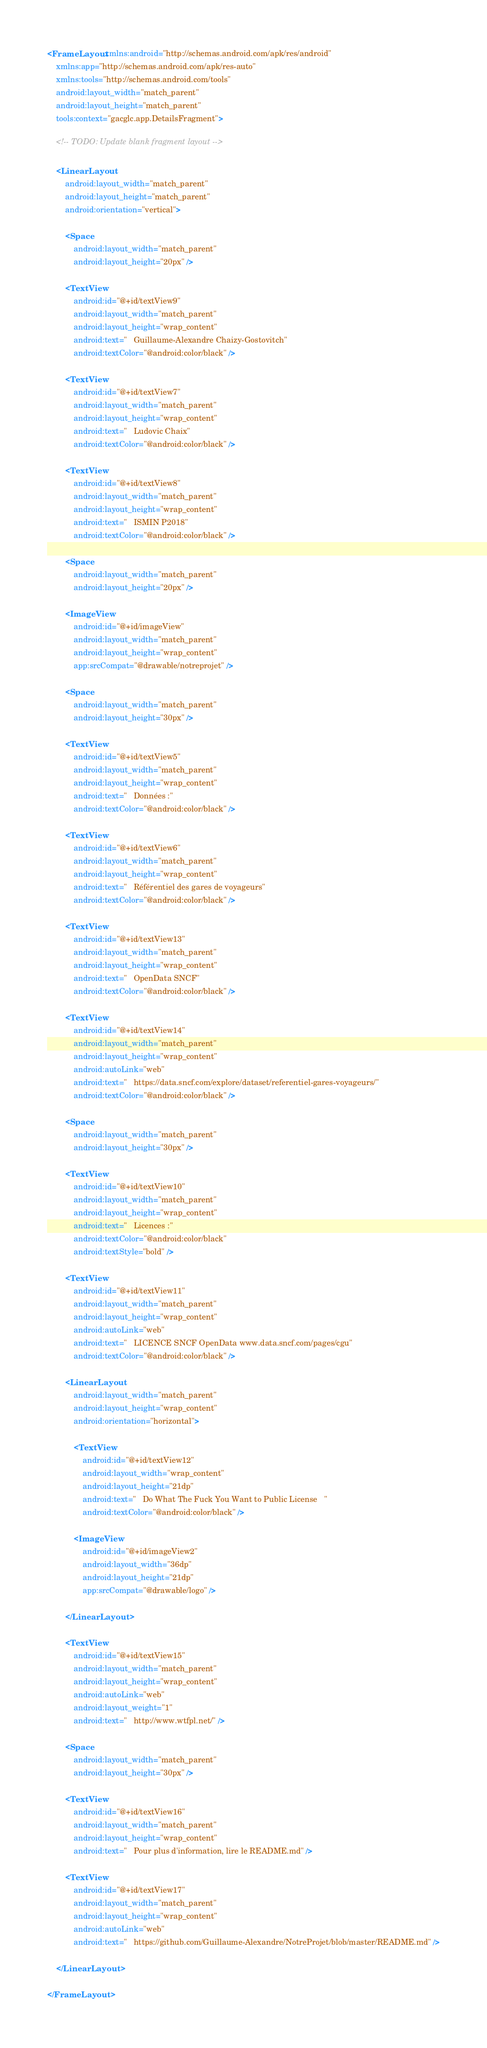Convert code to text. <code><loc_0><loc_0><loc_500><loc_500><_XML_><FrameLayout xmlns:android="http://schemas.android.com/apk/res/android"
    xmlns:app="http://schemas.android.com/apk/res-auto"
    xmlns:tools="http://schemas.android.com/tools"
    android:layout_width="match_parent"
    android:layout_height="match_parent"
    tools:context="gacglc.app.DetailsFragment">

    <!-- TODO: Update blank fragment layout -->

    <LinearLayout
        android:layout_width="match_parent"
        android:layout_height="match_parent"
        android:orientation="vertical">

        <Space
            android:layout_width="match_parent"
            android:layout_height="20px" />

        <TextView
            android:id="@+id/textView9"
            android:layout_width="match_parent"
            android:layout_height="wrap_content"
            android:text="   Guillaume-Alexandre Chaizy-Gostovitch"
            android:textColor="@android:color/black" />

        <TextView
            android:id="@+id/textView7"
            android:layout_width="match_parent"
            android:layout_height="wrap_content"
            android:text="   Ludovic Chaix"
            android:textColor="@android:color/black" />

        <TextView
            android:id="@+id/textView8"
            android:layout_width="match_parent"
            android:layout_height="wrap_content"
            android:text="   ISMIN P2018"
            android:textColor="@android:color/black" />

        <Space
            android:layout_width="match_parent"
            android:layout_height="20px" />

        <ImageView
            android:id="@+id/imageView"
            android:layout_width="match_parent"
            android:layout_height="wrap_content"
            app:srcCompat="@drawable/notreprojet" />

        <Space
            android:layout_width="match_parent"
            android:layout_height="30px" />

        <TextView
            android:id="@+id/textView5"
            android:layout_width="match_parent"
            android:layout_height="wrap_content"
            android:text="   Données :"
            android:textColor="@android:color/black" />

        <TextView
            android:id="@+id/textView6"
            android:layout_width="match_parent"
            android:layout_height="wrap_content"
            android:text="   Référentiel des gares de voyageurs"
            android:textColor="@android:color/black" />

        <TextView
            android:id="@+id/textView13"
            android:layout_width="match_parent"
            android:layout_height="wrap_content"
            android:text="   OpenData SNCF"
            android:textColor="@android:color/black" />

        <TextView
            android:id="@+id/textView14"
            android:layout_width="match_parent"
            android:layout_height="wrap_content"
            android:autoLink="web"
            android:text="   https://data.sncf.com/explore/dataset/referentiel-gares-voyageurs/"
            android:textColor="@android:color/black" />

        <Space
            android:layout_width="match_parent"
            android:layout_height="30px" />

        <TextView
            android:id="@+id/textView10"
            android:layout_width="match_parent"
            android:layout_height="wrap_content"
            android:text="   Licences :"
            android:textColor="@android:color/black"
            android:textStyle="bold" />

        <TextView
            android:id="@+id/textView11"
            android:layout_width="match_parent"
            android:layout_height="wrap_content"
            android:autoLink="web"
            android:text="   LICENCE SNCF OpenData www.data.sncf.com/pages/cgu"
            android:textColor="@android:color/black" />

        <LinearLayout
            android:layout_width="match_parent"
            android:layout_height="wrap_content"
            android:orientation="horizontal">

            <TextView
                android:id="@+id/textView12"
                android:layout_width="wrap_content"
                android:layout_height="21dp"
                android:text="   Do What The Fuck You Want to Public License   "
                android:textColor="@android:color/black" />

            <ImageView
                android:id="@+id/imageView2"
                android:layout_width="36dp"
                android:layout_height="21dp"
                app:srcCompat="@drawable/logo" />

        </LinearLayout>

        <TextView
            android:id="@+id/textView15"
            android:layout_width="match_parent"
            android:layout_height="wrap_content"
            android:autoLink="web"
            android:layout_weight="1"
            android:text="   http://www.wtfpl.net/" />

        <Space
            android:layout_width="match_parent"
            android:layout_height="30px" />

        <TextView
            android:id="@+id/textView16"
            android:layout_width="match_parent"
            android:layout_height="wrap_content"
            android:text="   Pour plus d'information, lire le README.md" />

        <TextView
            android:id="@+id/textView17"
            android:layout_width="match_parent"
            android:layout_height="wrap_content"
            android:autoLink="web"
            android:text="   https://github.com/Guillaume-Alexandre/NotreProjet/blob/master/README.md" />

    </LinearLayout>

</FrameLayout>
</code> 